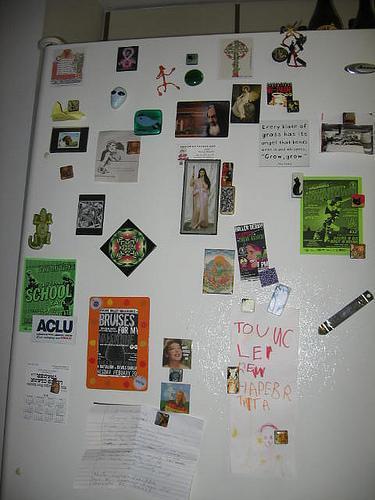How many frogs are there?
Give a very brief answer. 1. How many green papers are on the frig?
Give a very brief answer. 2. How many red pictures are there?
Give a very brief answer. 1. 